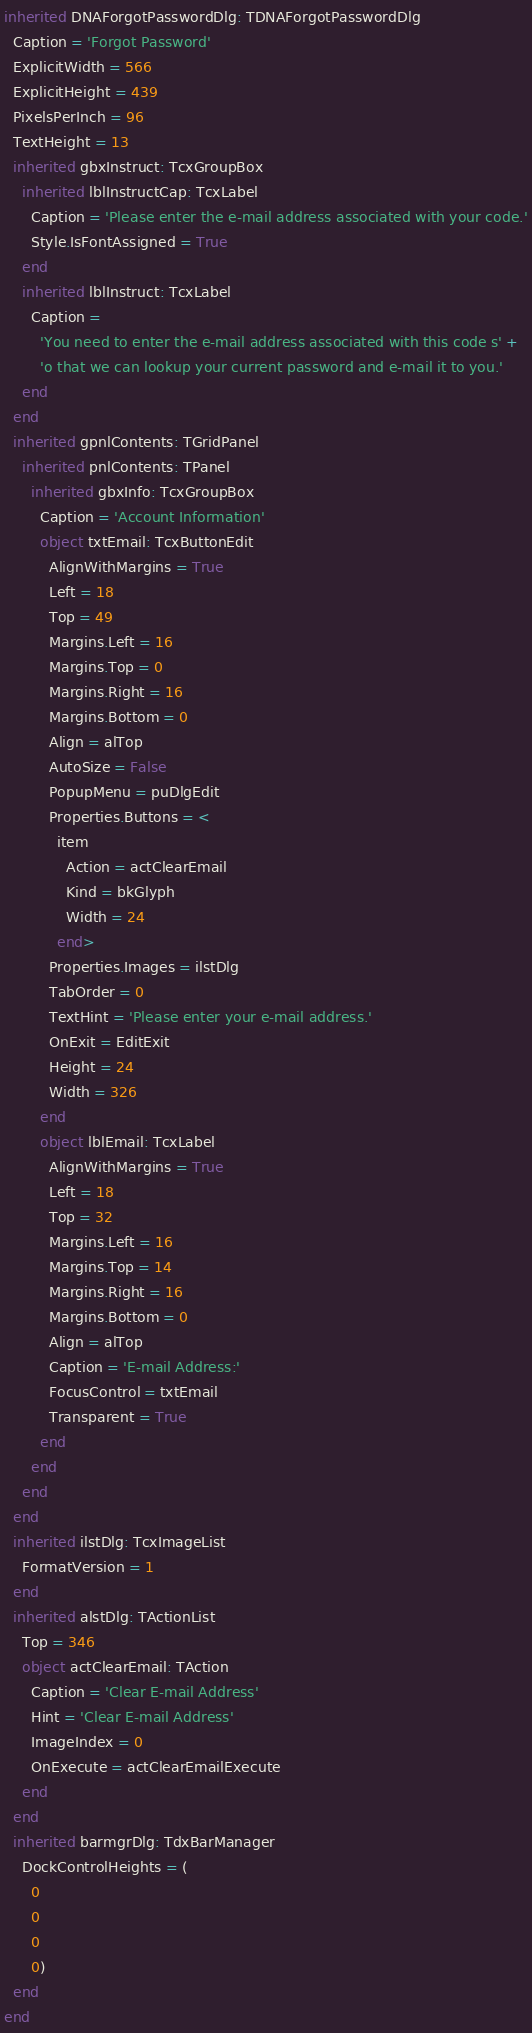Convert code to text. <code><loc_0><loc_0><loc_500><loc_500><_Pascal_>inherited DNAForgotPasswordDlg: TDNAForgotPasswordDlg
  Caption = 'Forgot Password'
  ExplicitWidth = 566
  ExplicitHeight = 439
  PixelsPerInch = 96
  TextHeight = 13
  inherited gbxInstruct: TcxGroupBox
    inherited lblInstructCap: TcxLabel
      Caption = 'Please enter the e-mail address associated with your code.'
      Style.IsFontAssigned = True
    end
    inherited lblInstruct: TcxLabel
      Caption = 
        'You need to enter the e-mail address associated with this code s' +
        'o that we can lookup your current password and e-mail it to you.'
    end
  end
  inherited gpnlContents: TGridPanel
    inherited pnlContents: TPanel
      inherited gbxInfo: TcxGroupBox
        Caption = 'Account Information'
        object txtEmail: TcxButtonEdit
          AlignWithMargins = True
          Left = 18
          Top = 49
          Margins.Left = 16
          Margins.Top = 0
          Margins.Right = 16
          Margins.Bottom = 0
          Align = alTop
          AutoSize = False
          PopupMenu = puDlgEdit
          Properties.Buttons = <
            item
              Action = actClearEmail
              Kind = bkGlyph
              Width = 24
            end>
          Properties.Images = ilstDlg
          TabOrder = 0
          TextHint = 'Please enter your e-mail address.'
          OnExit = EditExit
          Height = 24
          Width = 326
        end
        object lblEmail: TcxLabel
          AlignWithMargins = True
          Left = 18
          Top = 32
          Margins.Left = 16
          Margins.Top = 14
          Margins.Right = 16
          Margins.Bottom = 0
          Align = alTop
          Caption = 'E-mail Address:'
          FocusControl = txtEmail
          Transparent = True
        end
      end
    end
  end
  inherited ilstDlg: TcxImageList
    FormatVersion = 1
  end
  inherited alstDlg: TActionList
    Top = 346
    object actClearEmail: TAction
      Caption = 'Clear E-mail Address'
      Hint = 'Clear E-mail Address'
      ImageIndex = 0
      OnExecute = actClearEmailExecute
    end
  end
  inherited barmgrDlg: TdxBarManager
    DockControlHeights = (
      0
      0
      0
      0)
  end
end
</code> 